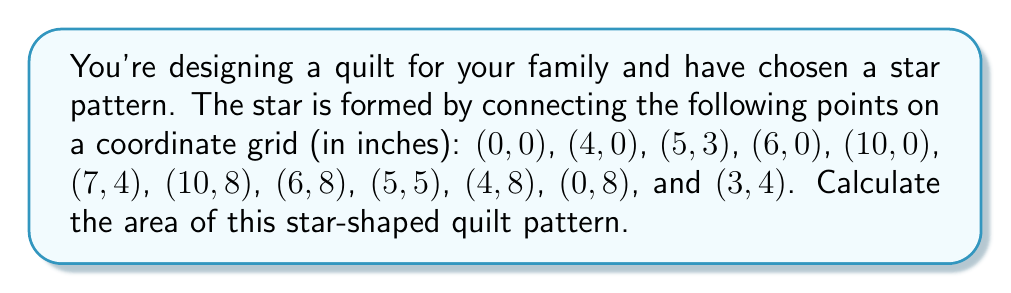Help me with this question. Let's approach this step-by-step:

1) The star can be divided into triangles for easier calculation.

2) We can split the star into 12 triangles:
   - 6 outer triangles
   - 6 inner triangles

3) For each triangle, we can use the formula:
   $$ A = \frac{1}{2}|x_1(y_2 - y_3) + x_2(y_3 - y_1) + x_3(y_1 - y_2)| $$

4) Let's calculate the areas:

   Outer triangles:
   $$ A_1 = \frac{1}{2}|0(0 - 4) + 4(4 - 8) + 10(8 - 0)| = 20 $$
   $$ A_2 = \frac{1}{2}|4(0 - 3) + 5(3 - 0) + 6(0 - 0)| = 1.5 $$
   $$ A_3 = \frac{1}{2}|6(0 - 4) + 10(4 - 8) + 10(8 - 0)| = 12 $$
   $$ A_4 = \frac{1}{2}|10(8 - 4) + 6(4 - 8) + 10(8 - 8)| = 12 $$
   $$ A_5 = \frac{1}{2}|6(8 - 5) + 4(5 - 8) + 0(8 - 8)| = 1.5 $$
   $$ A_6 = \frac{1}{2}|0(8 - 4) + 0(4 - 8) + 4(8 - 8)| = 20 $$

   Inner triangles:
   $$ A_7 = \frac{1}{2}|0(0 - 4) + 4(4 - 0) + 3(0 - 0)| = 8 $$
   $$ A_8 = \frac{1}{2}|4(0 - 3) + 5(3 - 0) + 3(0 - 0)| = 4.5 $$
   $$ A_9 = \frac{1}{2}|5(3 - 4) + 6(4 - 3) + 7(3 - 3)| = 0.5 $$
   $$ A_{10} = \frac{1}{2}|6(0 - 4) + 10(4 - 0) + 7(0 - 0)| = 8 $$
   $$ A_{11} = \frac{1}{2}|6(8 - 5) + 5(5 - 8) + 7(8 - 5)| = 4.5 $$
   $$ A_{12} = \frac{1}{2}|4(8 - 5) + 0(5 - 8) + 3(8 - 8)| = 6 $$

5) The total area is the sum of all these triangles:
   $$ A_{total} = 20 + 1.5 + 12 + 12 + 1.5 + 20 + 8 + 4.5 + 0.5 + 8 + 4.5 + 6 = 98.5 $$

Therefore, the area of the star-shaped quilt pattern is 98.5 square inches.
Answer: 98.5 square inches 